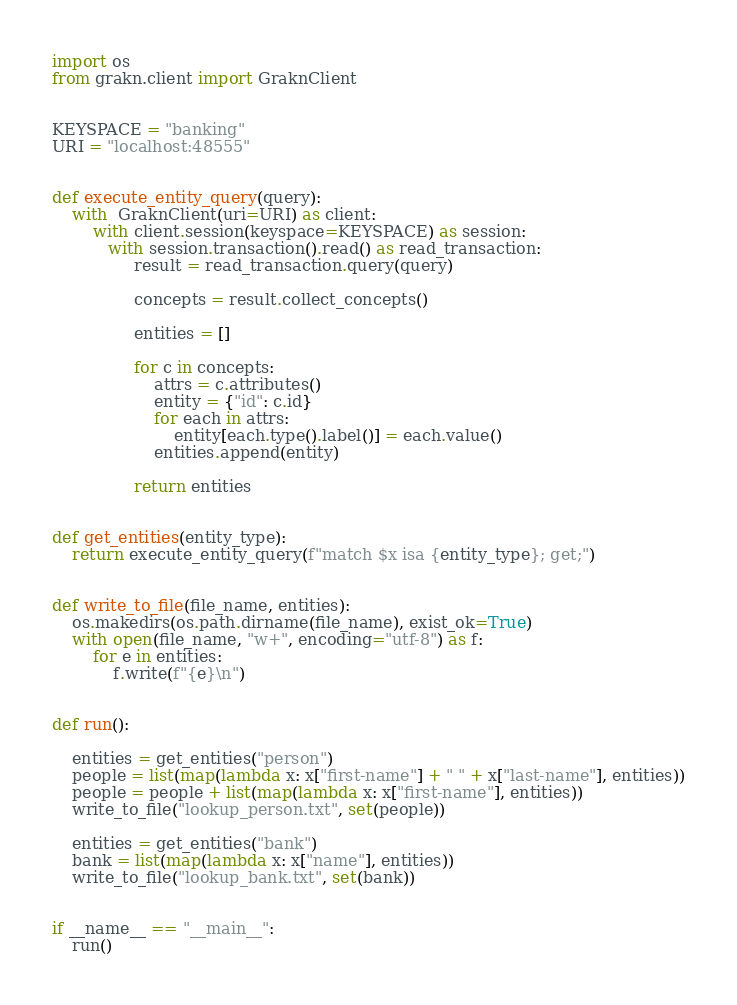Convert code to text. <code><loc_0><loc_0><loc_500><loc_500><_Python_>import os
from grakn.client import GraknClient


KEYSPACE = "banking"
URI = "localhost:48555"


def execute_entity_query(query):
    with  GraknClient(uri=URI) as client:
        with client.session(keyspace=KEYSPACE) as session:
           with session.transaction().read() as read_transaction:
                result = read_transaction.query(query)

                concepts = result.collect_concepts()

                entities = []

                for c in concepts:
                    attrs = c.attributes()
                    entity = {"id": c.id}
                    for each in attrs:
                        entity[each.type().label()] = each.value()
                    entities.append(entity)

                return entities


def get_entities(entity_type):
    return execute_entity_query(f"match $x isa {entity_type}; get;")


def write_to_file(file_name, entities):
    os.makedirs(os.path.dirname(file_name), exist_ok=True)
    with open(file_name, "w+", encoding="utf-8") as f:
        for e in entities:
            f.write(f"{e}\n")


def run():  

    entities = get_entities("person")
    people = list(map(lambda x: x["first-name"] + " " + x["last-name"], entities))
    people = people + list(map(lambda x: x["first-name"], entities))
    write_to_file("lookup_person.txt", set(people))

    entities = get_entities("bank")
    bank = list(map(lambda x: x["name"], entities))
    write_to_file("lookup_bank.txt", set(bank))


if __name__ == "__main__":
    run()
</code> 